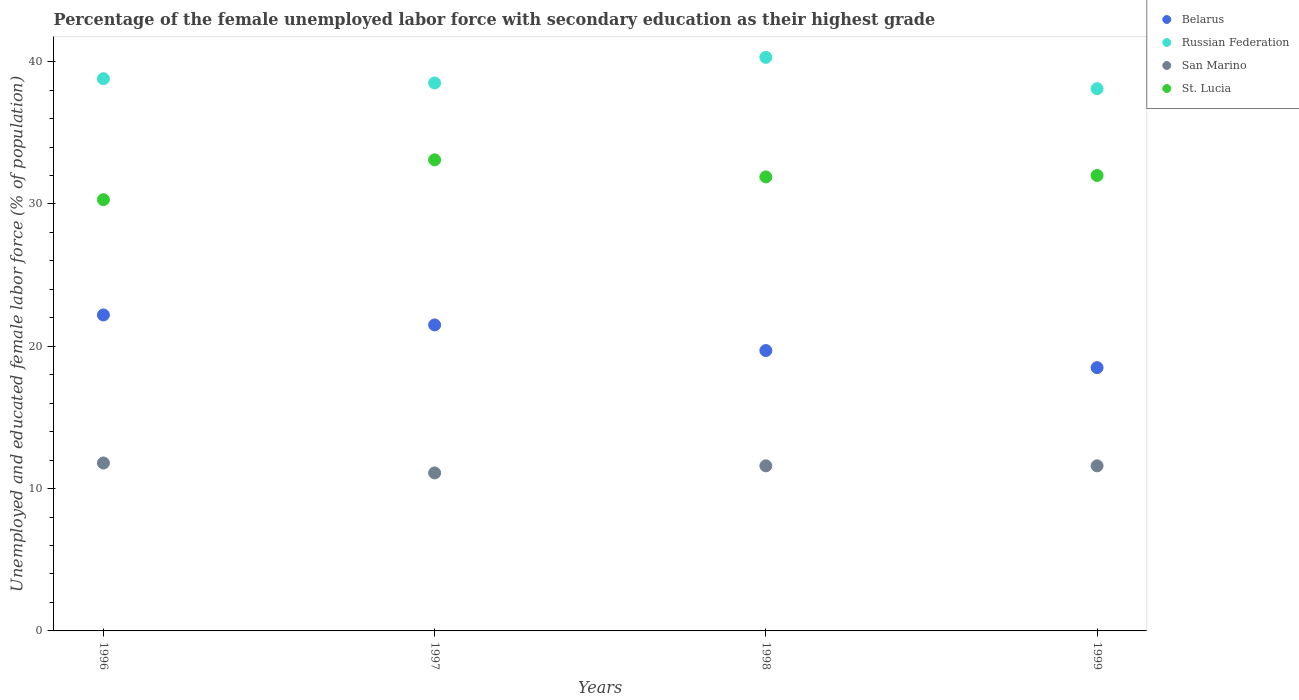How many different coloured dotlines are there?
Provide a short and direct response. 4. What is the percentage of the unemployed female labor force with secondary education in St. Lucia in 1996?
Your answer should be compact. 30.3. Across all years, what is the maximum percentage of the unemployed female labor force with secondary education in St. Lucia?
Your response must be concise. 33.1. Across all years, what is the minimum percentage of the unemployed female labor force with secondary education in Russian Federation?
Provide a short and direct response. 38.1. In which year was the percentage of the unemployed female labor force with secondary education in San Marino maximum?
Provide a succinct answer. 1996. In which year was the percentage of the unemployed female labor force with secondary education in Russian Federation minimum?
Your response must be concise. 1999. What is the total percentage of the unemployed female labor force with secondary education in San Marino in the graph?
Ensure brevity in your answer.  46.1. What is the difference between the percentage of the unemployed female labor force with secondary education in Russian Federation in 1998 and that in 1999?
Offer a terse response. 2.2. What is the difference between the percentage of the unemployed female labor force with secondary education in Belarus in 1998 and the percentage of the unemployed female labor force with secondary education in St. Lucia in 1997?
Give a very brief answer. -13.4. What is the average percentage of the unemployed female labor force with secondary education in Belarus per year?
Offer a very short reply. 20.48. In the year 1996, what is the difference between the percentage of the unemployed female labor force with secondary education in Russian Federation and percentage of the unemployed female labor force with secondary education in Belarus?
Your answer should be very brief. 16.6. What is the ratio of the percentage of the unemployed female labor force with secondary education in Belarus in 1996 to that in 1998?
Make the answer very short. 1.13. Is the percentage of the unemployed female labor force with secondary education in Belarus in 1997 less than that in 1999?
Your response must be concise. No. Is the difference between the percentage of the unemployed female labor force with secondary education in Russian Federation in 1998 and 1999 greater than the difference between the percentage of the unemployed female labor force with secondary education in Belarus in 1998 and 1999?
Ensure brevity in your answer.  Yes. What is the difference between the highest and the second highest percentage of the unemployed female labor force with secondary education in Russian Federation?
Provide a short and direct response. 1.5. What is the difference between the highest and the lowest percentage of the unemployed female labor force with secondary education in St. Lucia?
Ensure brevity in your answer.  2.8. In how many years, is the percentage of the unemployed female labor force with secondary education in St. Lucia greater than the average percentage of the unemployed female labor force with secondary education in St. Lucia taken over all years?
Your response must be concise. 3. Is it the case that in every year, the sum of the percentage of the unemployed female labor force with secondary education in St. Lucia and percentage of the unemployed female labor force with secondary education in San Marino  is greater than the sum of percentage of the unemployed female labor force with secondary education in Russian Federation and percentage of the unemployed female labor force with secondary education in Belarus?
Give a very brief answer. Yes. Is it the case that in every year, the sum of the percentage of the unemployed female labor force with secondary education in Belarus and percentage of the unemployed female labor force with secondary education in San Marino  is greater than the percentage of the unemployed female labor force with secondary education in St. Lucia?
Ensure brevity in your answer.  No. Does the percentage of the unemployed female labor force with secondary education in San Marino monotonically increase over the years?
Give a very brief answer. No. How many dotlines are there?
Keep it short and to the point. 4. Are the values on the major ticks of Y-axis written in scientific E-notation?
Provide a short and direct response. No. Where does the legend appear in the graph?
Give a very brief answer. Top right. How many legend labels are there?
Make the answer very short. 4. What is the title of the graph?
Ensure brevity in your answer.  Percentage of the female unemployed labor force with secondary education as their highest grade. What is the label or title of the Y-axis?
Provide a short and direct response. Unemployed and educated female labor force (% of population). What is the Unemployed and educated female labor force (% of population) of Belarus in 1996?
Ensure brevity in your answer.  22.2. What is the Unemployed and educated female labor force (% of population) of Russian Federation in 1996?
Offer a terse response. 38.8. What is the Unemployed and educated female labor force (% of population) in San Marino in 1996?
Ensure brevity in your answer.  11.8. What is the Unemployed and educated female labor force (% of population) in St. Lucia in 1996?
Keep it short and to the point. 30.3. What is the Unemployed and educated female labor force (% of population) in Russian Federation in 1997?
Give a very brief answer. 38.5. What is the Unemployed and educated female labor force (% of population) in San Marino in 1997?
Your answer should be very brief. 11.1. What is the Unemployed and educated female labor force (% of population) of St. Lucia in 1997?
Ensure brevity in your answer.  33.1. What is the Unemployed and educated female labor force (% of population) in Belarus in 1998?
Your answer should be very brief. 19.7. What is the Unemployed and educated female labor force (% of population) of Russian Federation in 1998?
Offer a very short reply. 40.3. What is the Unemployed and educated female labor force (% of population) in San Marino in 1998?
Give a very brief answer. 11.6. What is the Unemployed and educated female labor force (% of population) of St. Lucia in 1998?
Ensure brevity in your answer.  31.9. What is the Unemployed and educated female labor force (% of population) of Belarus in 1999?
Provide a succinct answer. 18.5. What is the Unemployed and educated female labor force (% of population) of Russian Federation in 1999?
Provide a short and direct response. 38.1. What is the Unemployed and educated female labor force (% of population) of San Marino in 1999?
Offer a very short reply. 11.6. Across all years, what is the maximum Unemployed and educated female labor force (% of population) in Belarus?
Provide a short and direct response. 22.2. Across all years, what is the maximum Unemployed and educated female labor force (% of population) in Russian Federation?
Keep it short and to the point. 40.3. Across all years, what is the maximum Unemployed and educated female labor force (% of population) of San Marino?
Your answer should be very brief. 11.8. Across all years, what is the maximum Unemployed and educated female labor force (% of population) in St. Lucia?
Your answer should be compact. 33.1. Across all years, what is the minimum Unemployed and educated female labor force (% of population) in Russian Federation?
Make the answer very short. 38.1. Across all years, what is the minimum Unemployed and educated female labor force (% of population) of San Marino?
Provide a short and direct response. 11.1. Across all years, what is the minimum Unemployed and educated female labor force (% of population) of St. Lucia?
Your answer should be very brief. 30.3. What is the total Unemployed and educated female labor force (% of population) of Belarus in the graph?
Your answer should be very brief. 81.9. What is the total Unemployed and educated female labor force (% of population) of Russian Federation in the graph?
Your answer should be very brief. 155.7. What is the total Unemployed and educated female labor force (% of population) in San Marino in the graph?
Your answer should be very brief. 46.1. What is the total Unemployed and educated female labor force (% of population) in St. Lucia in the graph?
Offer a terse response. 127.3. What is the difference between the Unemployed and educated female labor force (% of population) of Russian Federation in 1996 and that in 1997?
Provide a short and direct response. 0.3. What is the difference between the Unemployed and educated female labor force (% of population) of San Marino in 1996 and that in 1997?
Your answer should be very brief. 0.7. What is the difference between the Unemployed and educated female labor force (% of population) of St. Lucia in 1996 and that in 1998?
Give a very brief answer. -1.6. What is the difference between the Unemployed and educated female labor force (% of population) in Belarus in 1996 and that in 1999?
Offer a terse response. 3.7. What is the difference between the Unemployed and educated female labor force (% of population) in St. Lucia in 1996 and that in 1999?
Offer a terse response. -1.7. What is the difference between the Unemployed and educated female labor force (% of population) in Belarus in 1997 and that in 1998?
Offer a terse response. 1.8. What is the difference between the Unemployed and educated female labor force (% of population) of Russian Federation in 1997 and that in 1998?
Keep it short and to the point. -1.8. What is the difference between the Unemployed and educated female labor force (% of population) of San Marino in 1997 and that in 1998?
Provide a succinct answer. -0.5. What is the difference between the Unemployed and educated female labor force (% of population) of St. Lucia in 1997 and that in 1998?
Provide a short and direct response. 1.2. What is the difference between the Unemployed and educated female labor force (% of population) of Russian Federation in 1997 and that in 1999?
Your response must be concise. 0.4. What is the difference between the Unemployed and educated female labor force (% of population) in St. Lucia in 1997 and that in 1999?
Your answer should be compact. 1.1. What is the difference between the Unemployed and educated female labor force (% of population) in Russian Federation in 1998 and that in 1999?
Provide a succinct answer. 2.2. What is the difference between the Unemployed and educated female labor force (% of population) in San Marino in 1998 and that in 1999?
Keep it short and to the point. 0. What is the difference between the Unemployed and educated female labor force (% of population) of Belarus in 1996 and the Unemployed and educated female labor force (% of population) of Russian Federation in 1997?
Provide a short and direct response. -16.3. What is the difference between the Unemployed and educated female labor force (% of population) of Belarus in 1996 and the Unemployed and educated female labor force (% of population) of San Marino in 1997?
Make the answer very short. 11.1. What is the difference between the Unemployed and educated female labor force (% of population) in Russian Federation in 1996 and the Unemployed and educated female labor force (% of population) in San Marino in 1997?
Give a very brief answer. 27.7. What is the difference between the Unemployed and educated female labor force (% of population) of San Marino in 1996 and the Unemployed and educated female labor force (% of population) of St. Lucia in 1997?
Your response must be concise. -21.3. What is the difference between the Unemployed and educated female labor force (% of population) of Belarus in 1996 and the Unemployed and educated female labor force (% of population) of Russian Federation in 1998?
Your answer should be very brief. -18.1. What is the difference between the Unemployed and educated female labor force (% of population) of Russian Federation in 1996 and the Unemployed and educated female labor force (% of population) of San Marino in 1998?
Offer a very short reply. 27.2. What is the difference between the Unemployed and educated female labor force (% of population) in Russian Federation in 1996 and the Unemployed and educated female labor force (% of population) in St. Lucia in 1998?
Your response must be concise. 6.9. What is the difference between the Unemployed and educated female labor force (% of population) of San Marino in 1996 and the Unemployed and educated female labor force (% of population) of St. Lucia in 1998?
Provide a short and direct response. -20.1. What is the difference between the Unemployed and educated female labor force (% of population) in Belarus in 1996 and the Unemployed and educated female labor force (% of population) in Russian Federation in 1999?
Offer a very short reply. -15.9. What is the difference between the Unemployed and educated female labor force (% of population) in Belarus in 1996 and the Unemployed and educated female labor force (% of population) in San Marino in 1999?
Provide a short and direct response. 10.6. What is the difference between the Unemployed and educated female labor force (% of population) of Belarus in 1996 and the Unemployed and educated female labor force (% of population) of St. Lucia in 1999?
Provide a short and direct response. -9.8. What is the difference between the Unemployed and educated female labor force (% of population) of Russian Federation in 1996 and the Unemployed and educated female labor force (% of population) of San Marino in 1999?
Make the answer very short. 27.2. What is the difference between the Unemployed and educated female labor force (% of population) of Russian Federation in 1996 and the Unemployed and educated female labor force (% of population) of St. Lucia in 1999?
Keep it short and to the point. 6.8. What is the difference between the Unemployed and educated female labor force (% of population) of San Marino in 1996 and the Unemployed and educated female labor force (% of population) of St. Lucia in 1999?
Ensure brevity in your answer.  -20.2. What is the difference between the Unemployed and educated female labor force (% of population) in Belarus in 1997 and the Unemployed and educated female labor force (% of population) in Russian Federation in 1998?
Your response must be concise. -18.8. What is the difference between the Unemployed and educated female labor force (% of population) in Belarus in 1997 and the Unemployed and educated female labor force (% of population) in St. Lucia in 1998?
Provide a succinct answer. -10.4. What is the difference between the Unemployed and educated female labor force (% of population) of Russian Federation in 1997 and the Unemployed and educated female labor force (% of population) of San Marino in 1998?
Give a very brief answer. 26.9. What is the difference between the Unemployed and educated female labor force (% of population) in Russian Federation in 1997 and the Unemployed and educated female labor force (% of population) in St. Lucia in 1998?
Give a very brief answer. 6.6. What is the difference between the Unemployed and educated female labor force (% of population) of San Marino in 1997 and the Unemployed and educated female labor force (% of population) of St. Lucia in 1998?
Your answer should be compact. -20.8. What is the difference between the Unemployed and educated female labor force (% of population) in Belarus in 1997 and the Unemployed and educated female labor force (% of population) in Russian Federation in 1999?
Your answer should be compact. -16.6. What is the difference between the Unemployed and educated female labor force (% of population) in Russian Federation in 1997 and the Unemployed and educated female labor force (% of population) in San Marino in 1999?
Keep it short and to the point. 26.9. What is the difference between the Unemployed and educated female labor force (% of population) of Russian Federation in 1997 and the Unemployed and educated female labor force (% of population) of St. Lucia in 1999?
Provide a short and direct response. 6.5. What is the difference between the Unemployed and educated female labor force (% of population) of San Marino in 1997 and the Unemployed and educated female labor force (% of population) of St. Lucia in 1999?
Provide a succinct answer. -20.9. What is the difference between the Unemployed and educated female labor force (% of population) of Belarus in 1998 and the Unemployed and educated female labor force (% of population) of Russian Federation in 1999?
Give a very brief answer. -18.4. What is the difference between the Unemployed and educated female labor force (% of population) in Belarus in 1998 and the Unemployed and educated female labor force (% of population) in San Marino in 1999?
Give a very brief answer. 8.1. What is the difference between the Unemployed and educated female labor force (% of population) of Russian Federation in 1998 and the Unemployed and educated female labor force (% of population) of San Marino in 1999?
Your answer should be compact. 28.7. What is the difference between the Unemployed and educated female labor force (% of population) of Russian Federation in 1998 and the Unemployed and educated female labor force (% of population) of St. Lucia in 1999?
Ensure brevity in your answer.  8.3. What is the difference between the Unemployed and educated female labor force (% of population) of San Marino in 1998 and the Unemployed and educated female labor force (% of population) of St. Lucia in 1999?
Your response must be concise. -20.4. What is the average Unemployed and educated female labor force (% of population) in Belarus per year?
Your answer should be compact. 20.48. What is the average Unemployed and educated female labor force (% of population) of Russian Federation per year?
Provide a short and direct response. 38.92. What is the average Unemployed and educated female labor force (% of population) in San Marino per year?
Offer a terse response. 11.53. What is the average Unemployed and educated female labor force (% of population) in St. Lucia per year?
Offer a very short reply. 31.82. In the year 1996, what is the difference between the Unemployed and educated female labor force (% of population) of Belarus and Unemployed and educated female labor force (% of population) of Russian Federation?
Keep it short and to the point. -16.6. In the year 1996, what is the difference between the Unemployed and educated female labor force (% of population) in San Marino and Unemployed and educated female labor force (% of population) in St. Lucia?
Offer a terse response. -18.5. In the year 1997, what is the difference between the Unemployed and educated female labor force (% of population) of Belarus and Unemployed and educated female labor force (% of population) of Russian Federation?
Your answer should be compact. -17. In the year 1997, what is the difference between the Unemployed and educated female labor force (% of population) of Belarus and Unemployed and educated female labor force (% of population) of St. Lucia?
Provide a short and direct response. -11.6. In the year 1997, what is the difference between the Unemployed and educated female labor force (% of population) in Russian Federation and Unemployed and educated female labor force (% of population) in San Marino?
Provide a succinct answer. 27.4. In the year 1998, what is the difference between the Unemployed and educated female labor force (% of population) of Belarus and Unemployed and educated female labor force (% of population) of Russian Federation?
Your answer should be compact. -20.6. In the year 1998, what is the difference between the Unemployed and educated female labor force (% of population) of Belarus and Unemployed and educated female labor force (% of population) of San Marino?
Offer a terse response. 8.1. In the year 1998, what is the difference between the Unemployed and educated female labor force (% of population) of Belarus and Unemployed and educated female labor force (% of population) of St. Lucia?
Your answer should be very brief. -12.2. In the year 1998, what is the difference between the Unemployed and educated female labor force (% of population) in Russian Federation and Unemployed and educated female labor force (% of population) in San Marino?
Provide a short and direct response. 28.7. In the year 1998, what is the difference between the Unemployed and educated female labor force (% of population) of San Marino and Unemployed and educated female labor force (% of population) of St. Lucia?
Keep it short and to the point. -20.3. In the year 1999, what is the difference between the Unemployed and educated female labor force (% of population) in Belarus and Unemployed and educated female labor force (% of population) in Russian Federation?
Make the answer very short. -19.6. In the year 1999, what is the difference between the Unemployed and educated female labor force (% of population) in Belarus and Unemployed and educated female labor force (% of population) in St. Lucia?
Your answer should be very brief. -13.5. In the year 1999, what is the difference between the Unemployed and educated female labor force (% of population) in Russian Federation and Unemployed and educated female labor force (% of population) in San Marino?
Keep it short and to the point. 26.5. In the year 1999, what is the difference between the Unemployed and educated female labor force (% of population) in Russian Federation and Unemployed and educated female labor force (% of population) in St. Lucia?
Offer a very short reply. 6.1. In the year 1999, what is the difference between the Unemployed and educated female labor force (% of population) of San Marino and Unemployed and educated female labor force (% of population) of St. Lucia?
Make the answer very short. -20.4. What is the ratio of the Unemployed and educated female labor force (% of population) in Belarus in 1996 to that in 1997?
Your answer should be very brief. 1.03. What is the ratio of the Unemployed and educated female labor force (% of population) in Russian Federation in 1996 to that in 1997?
Provide a succinct answer. 1.01. What is the ratio of the Unemployed and educated female labor force (% of population) in San Marino in 1996 to that in 1997?
Provide a succinct answer. 1.06. What is the ratio of the Unemployed and educated female labor force (% of population) in St. Lucia in 1996 to that in 1997?
Keep it short and to the point. 0.92. What is the ratio of the Unemployed and educated female labor force (% of population) in Belarus in 1996 to that in 1998?
Offer a terse response. 1.13. What is the ratio of the Unemployed and educated female labor force (% of population) of Russian Federation in 1996 to that in 1998?
Your answer should be compact. 0.96. What is the ratio of the Unemployed and educated female labor force (% of population) in San Marino in 1996 to that in 1998?
Make the answer very short. 1.02. What is the ratio of the Unemployed and educated female labor force (% of population) in St. Lucia in 1996 to that in 1998?
Give a very brief answer. 0.95. What is the ratio of the Unemployed and educated female labor force (% of population) of Russian Federation in 1996 to that in 1999?
Make the answer very short. 1.02. What is the ratio of the Unemployed and educated female labor force (% of population) in San Marino in 1996 to that in 1999?
Your response must be concise. 1.02. What is the ratio of the Unemployed and educated female labor force (% of population) of St. Lucia in 1996 to that in 1999?
Keep it short and to the point. 0.95. What is the ratio of the Unemployed and educated female labor force (% of population) in Belarus in 1997 to that in 1998?
Ensure brevity in your answer.  1.09. What is the ratio of the Unemployed and educated female labor force (% of population) of Russian Federation in 1997 to that in 1998?
Keep it short and to the point. 0.96. What is the ratio of the Unemployed and educated female labor force (% of population) in San Marino in 1997 to that in 1998?
Provide a succinct answer. 0.96. What is the ratio of the Unemployed and educated female labor force (% of population) in St. Lucia in 1997 to that in 1998?
Offer a very short reply. 1.04. What is the ratio of the Unemployed and educated female labor force (% of population) of Belarus in 1997 to that in 1999?
Provide a succinct answer. 1.16. What is the ratio of the Unemployed and educated female labor force (% of population) in Russian Federation in 1997 to that in 1999?
Your response must be concise. 1.01. What is the ratio of the Unemployed and educated female labor force (% of population) of San Marino in 1997 to that in 1999?
Provide a succinct answer. 0.96. What is the ratio of the Unemployed and educated female labor force (% of population) of St. Lucia in 1997 to that in 1999?
Your answer should be compact. 1.03. What is the ratio of the Unemployed and educated female labor force (% of population) of Belarus in 1998 to that in 1999?
Your response must be concise. 1.06. What is the ratio of the Unemployed and educated female labor force (% of population) of Russian Federation in 1998 to that in 1999?
Ensure brevity in your answer.  1.06. What is the ratio of the Unemployed and educated female labor force (% of population) of St. Lucia in 1998 to that in 1999?
Your answer should be very brief. 1. What is the difference between the highest and the second highest Unemployed and educated female labor force (% of population) of Russian Federation?
Your answer should be compact. 1.5. What is the difference between the highest and the lowest Unemployed and educated female labor force (% of population) in Belarus?
Offer a terse response. 3.7. What is the difference between the highest and the lowest Unemployed and educated female labor force (% of population) in St. Lucia?
Ensure brevity in your answer.  2.8. 